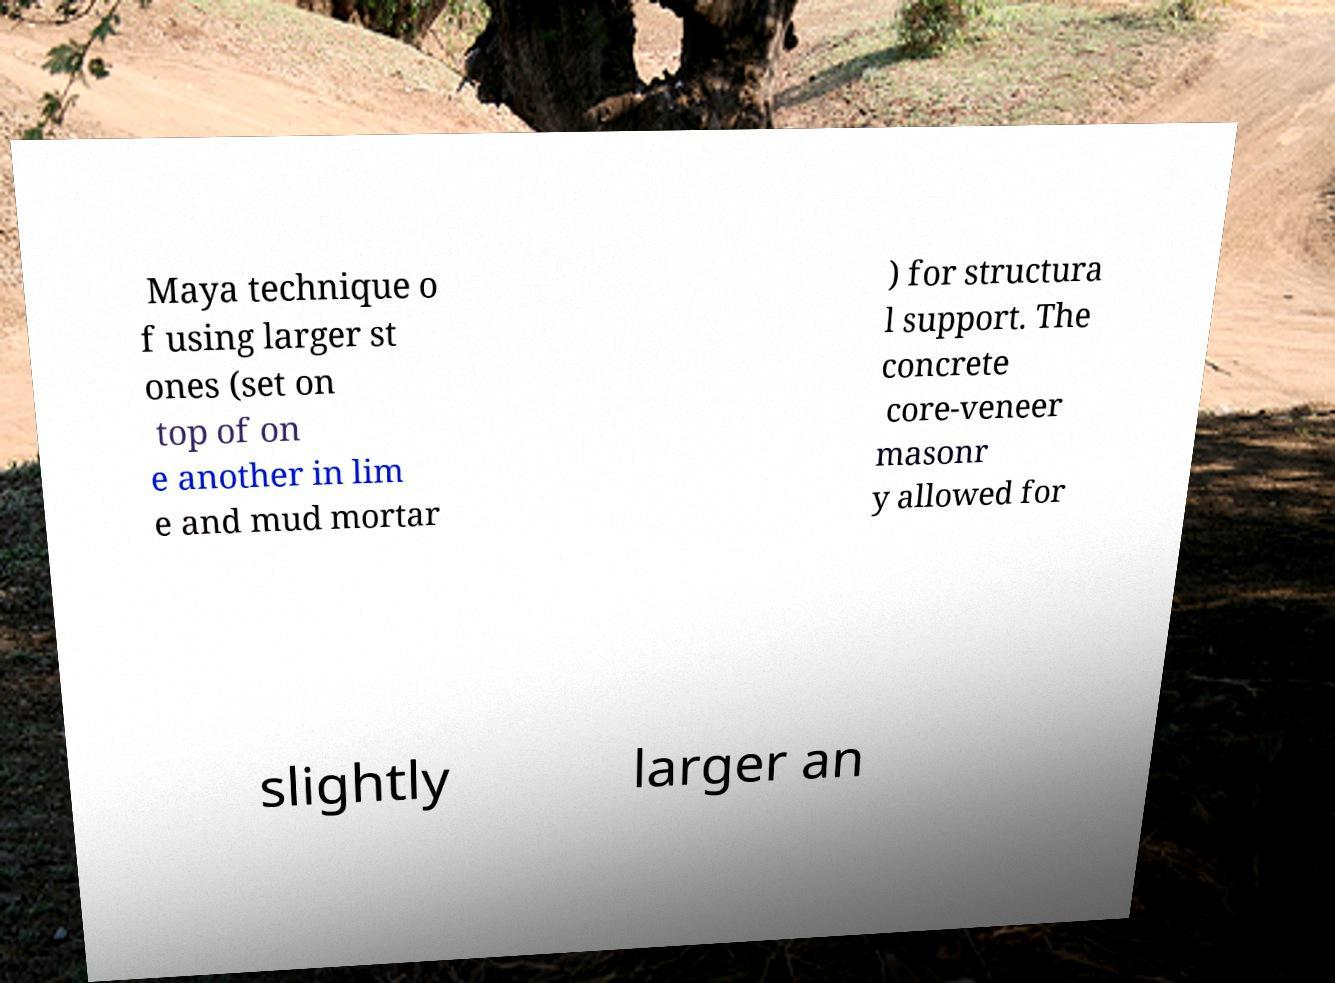Could you assist in decoding the text presented in this image and type it out clearly? Maya technique o f using larger st ones (set on top of on e another in lim e and mud mortar ) for structura l support. The concrete core-veneer masonr y allowed for slightly larger an 